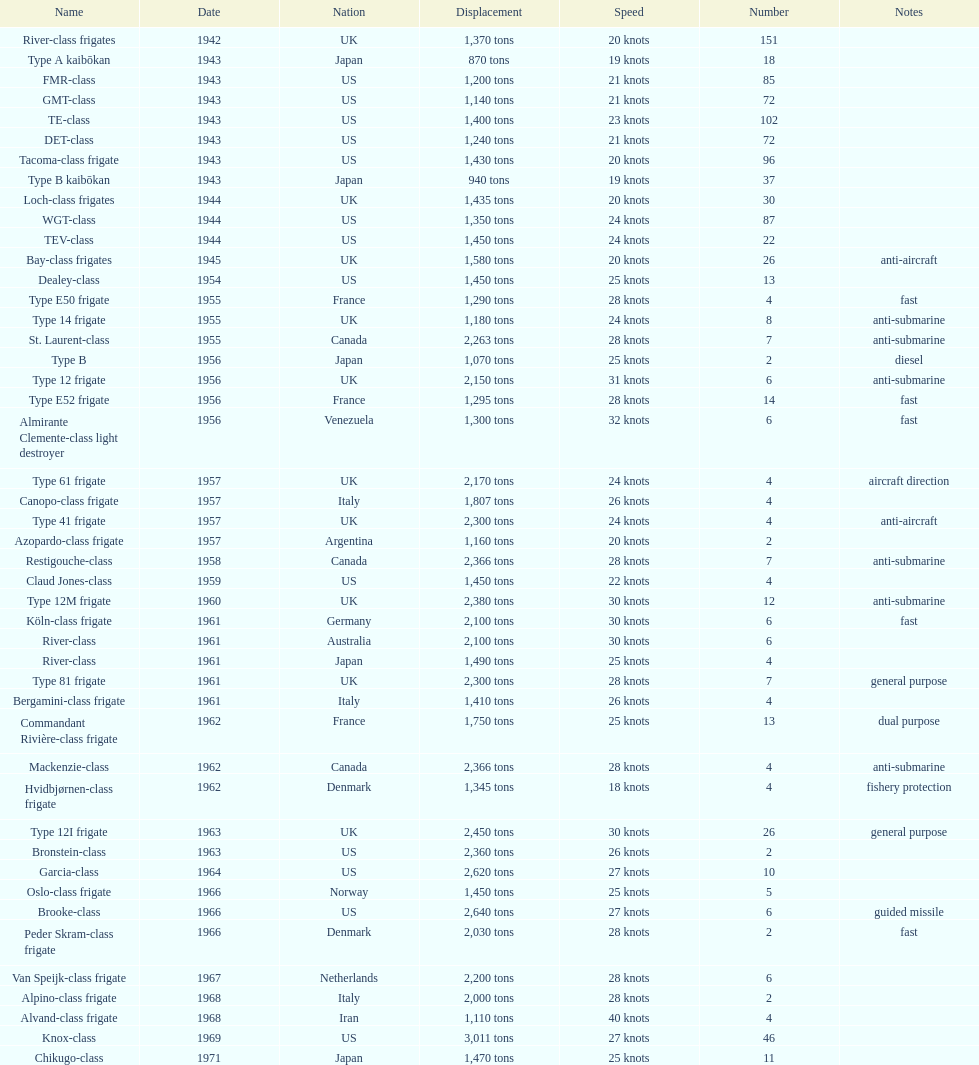How many successive escorts were there in 1943? 7. 